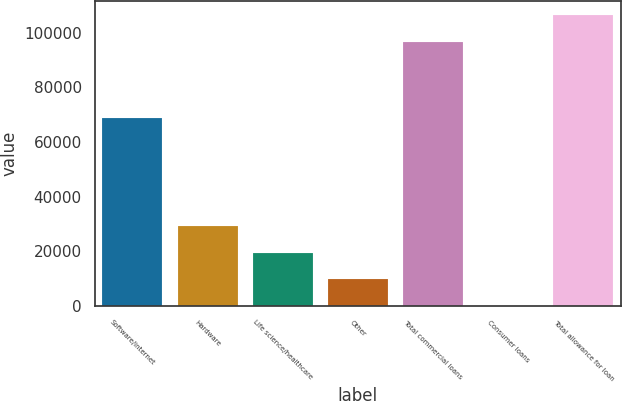Convert chart to OTSL. <chart><loc_0><loc_0><loc_500><loc_500><bar_chart><fcel>Software/internet<fcel>Hardware<fcel>Life science/healthcare<fcel>Other<fcel>Total commercial loans<fcel>Consumer loans<fcel>Total allowance for loan<nl><fcel>68784<fcel>29128.5<fcel>19453<fcel>9777.5<fcel>96755<fcel>102<fcel>106430<nl></chart> 